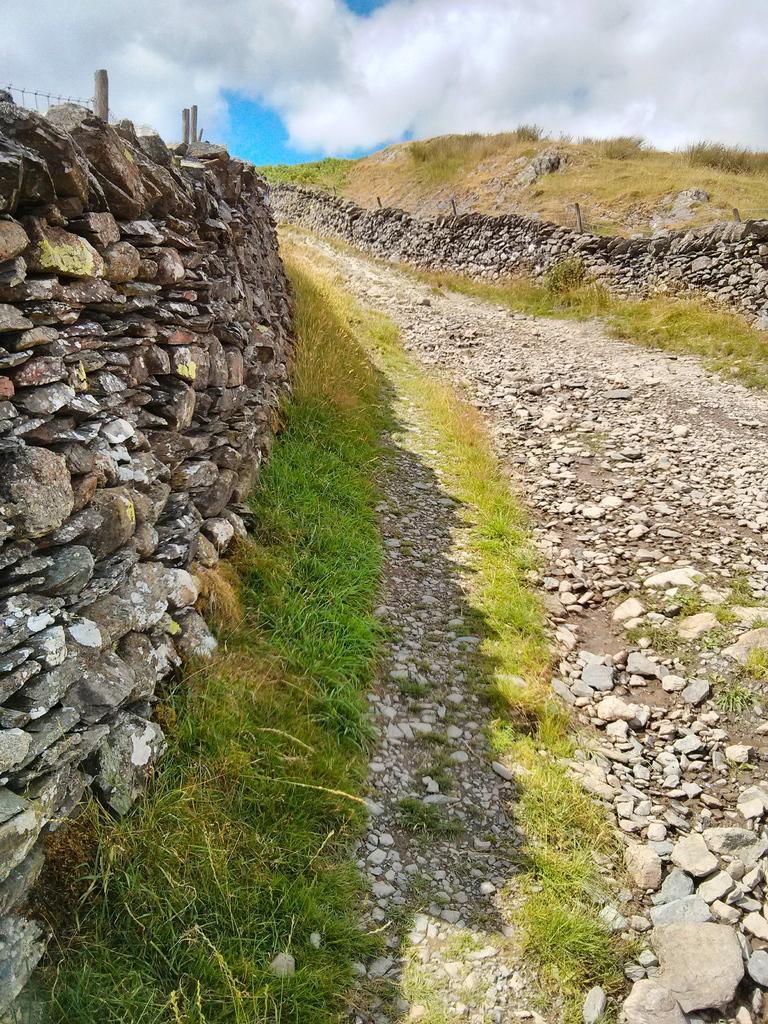Can you describe this image briefly? In this image there is the sky truncated towards the top of the image, there are clouds in the sky, there is grass truncated towards the right of the image, there are rocks truncated towards the right of the image, there is the grass truncated towards the bottom of the image, there are stones on the ground, there is a wall truncated towards the left of the image. 